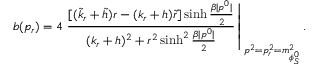<formula> <loc_0><loc_0><loc_500><loc_500>b ( p _ { r } ) = 4 \frac { [ ( \tilde { k } _ { r } + \tilde { h } ) r - ( k _ { r } + h ) \tilde { r } ] \sinh \frac { \beta | p ^ { 0 } | } { 2 } } { ( k _ { r } + h ) ^ { 2 } + r ^ { 2 } \sinh ^ { 2 } \frac { \beta | p ^ { 0 } | } { 2 } } \right | _ { p ^ { 2 } = p _ { r } ^ { 2 } = m _ { \phi _ { S } ^ { 0 } } ^ { 2 } } .</formula> 